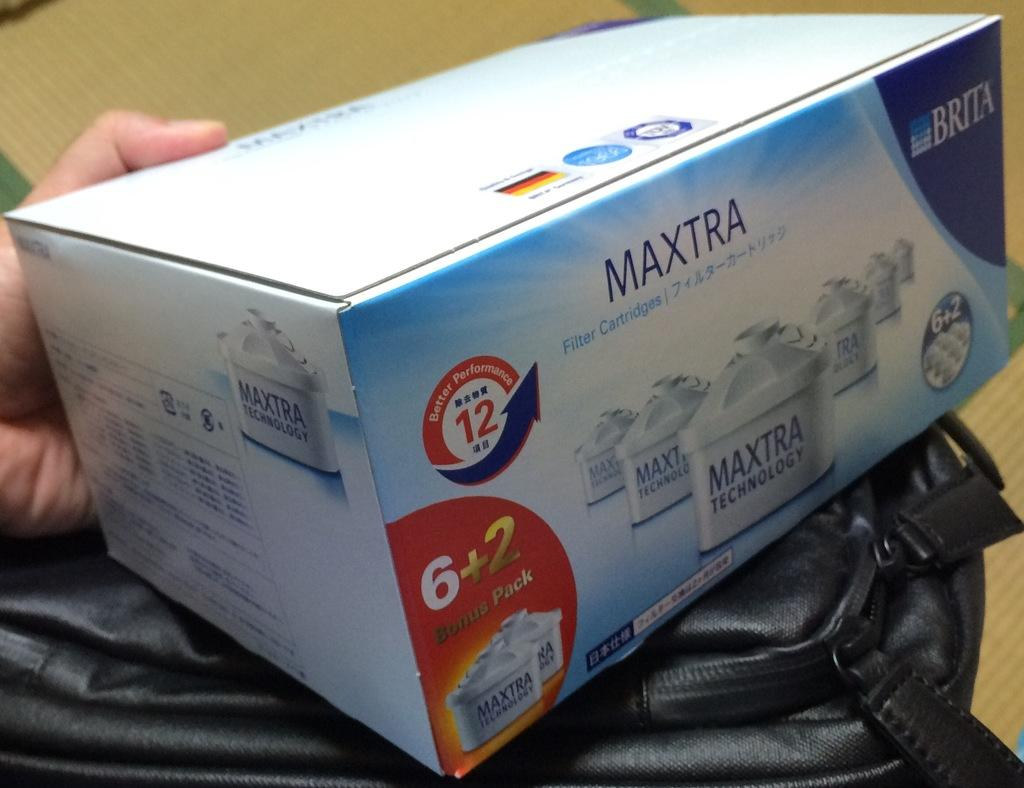<image>
Present a compact description of the photo's key features. A box of Maxtra Filter Cartridges is on top of a black bag. 